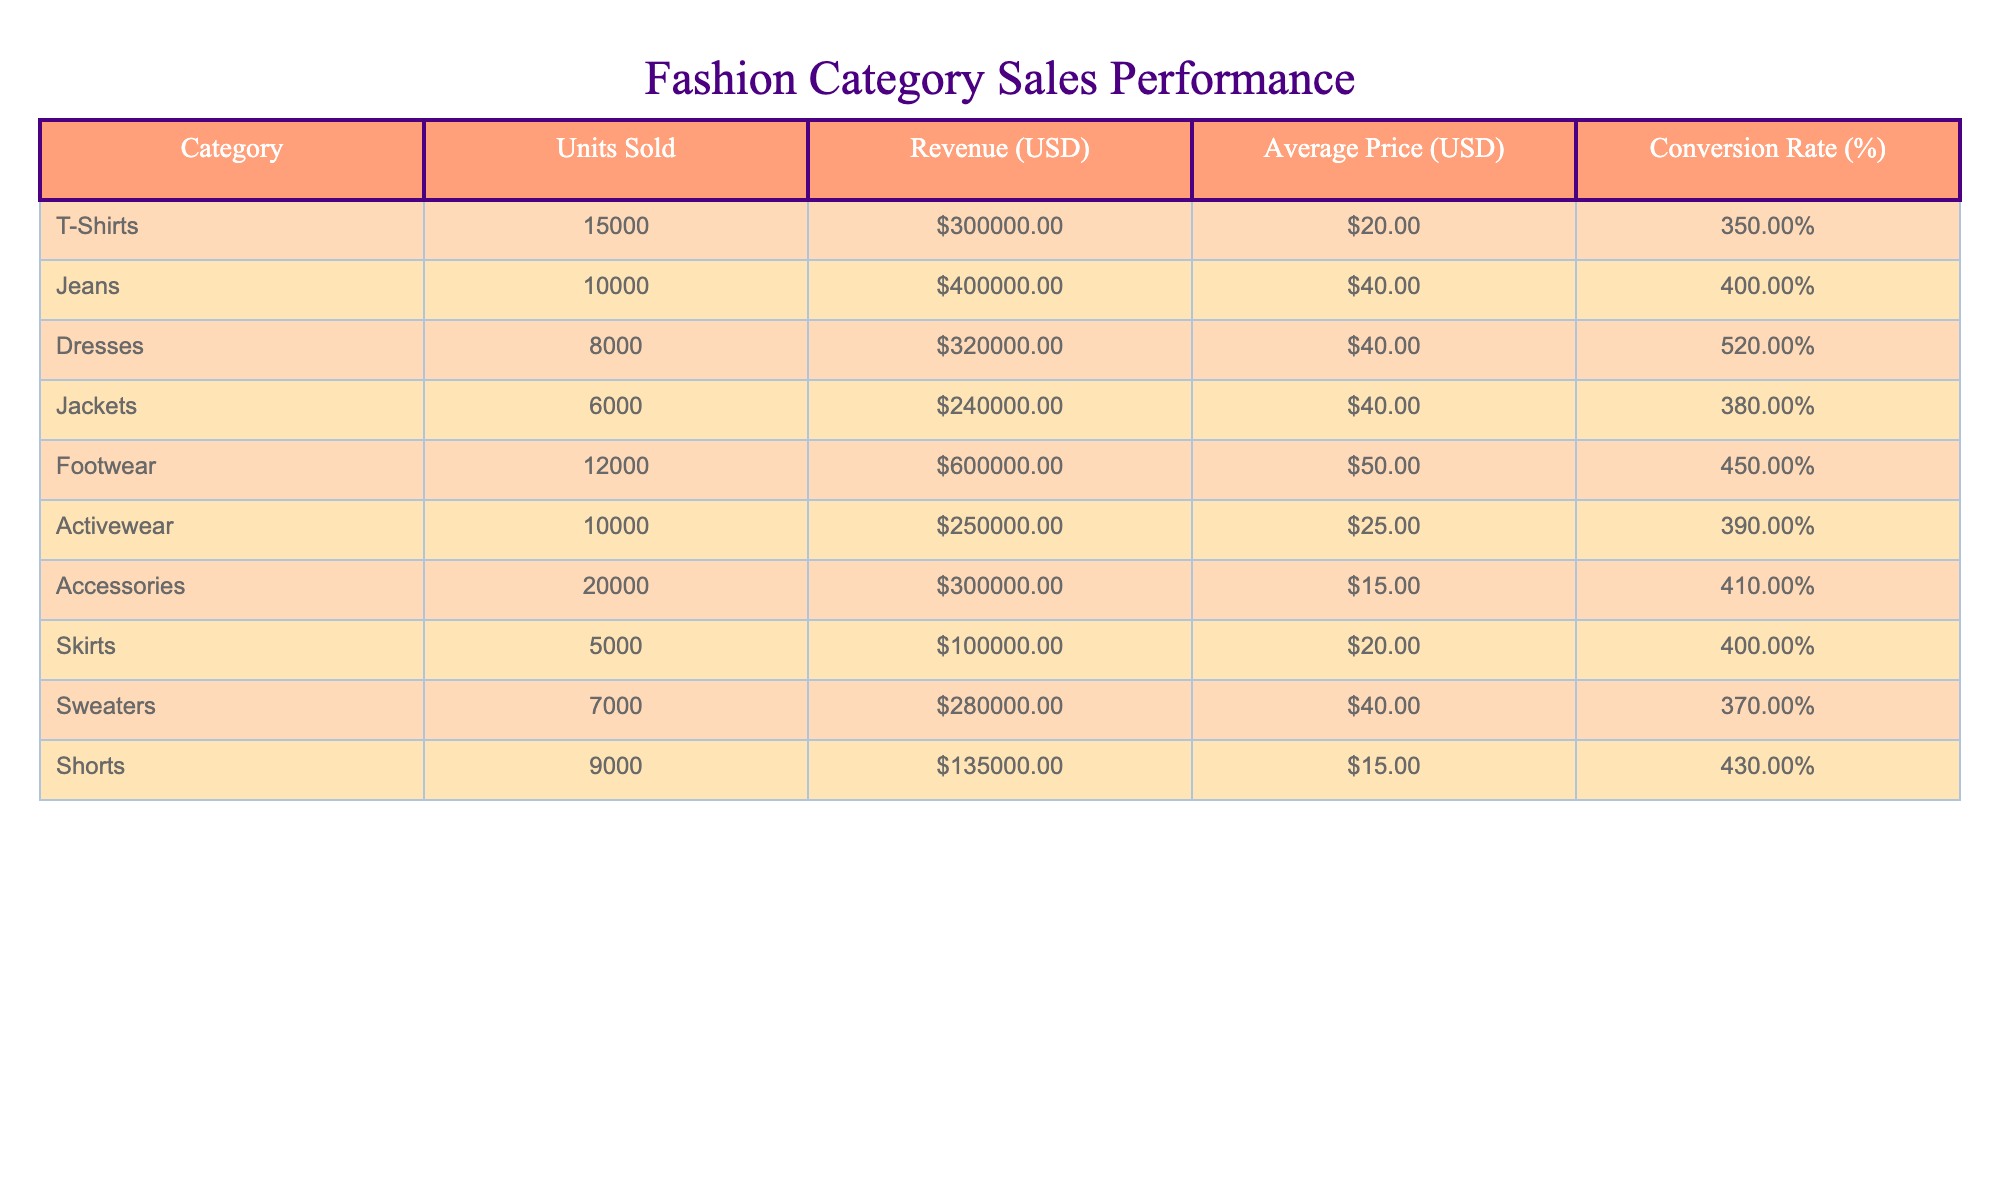What clothing category had the highest revenue? By examining the "Revenue (USD)" column, we see that Footwear generated the most at 600,000 USD.
Answer: Footwear How many units were sold for Dresses? The "Units Sold" column shows that 8,000 units were sold for Dresses.
Answer: 8000 What is the average price of Activewear? The "Average Price (USD)" for Activewear is listed as 25 USD.
Answer: 25 USD Which category has the highest conversion rate? Looking at the "Conversion Rate (%)" column, Dresses has the highest conversion rate at 5.2%.
Answer: Dresses What is the total revenue generated by Skirts and Sweaters combined? For Skirts, the revenue is 100,000 USD, and for Sweaters, it is 280,000 USD. Adding these together: 100,000 + 280,000 = 380,000 USD.
Answer: 380,000 USD Did more units sell in Accessories or Shorts? Accessories sold 20,000 units while Shorts sold 9,000 units, meaning Accessories sold more.
Answer: Yes What is the average revenue per unit sold for Jeans? The revenue for Jeans is 400,000 USD and 10,000 units were sold. Therefore, the average revenue per unit is 400,000 / 10,000 = 40 USD.
Answer: 40 USD Which category had the lowest conversion rate and what was it? By checking the "Conversion Rate (%)" column, we find that T-Shirts had the lowest with a rate of 3.5%.
Answer: T-Shirts, 3.5% If we consider the total units sold for Footwear and Accessories, what is that total? Footwear sold 12,000 units and Accessories sold 20,000 units. Adding these gives a total of 12,000 + 20,000 = 32,000 units.
Answer: 32,000 units 